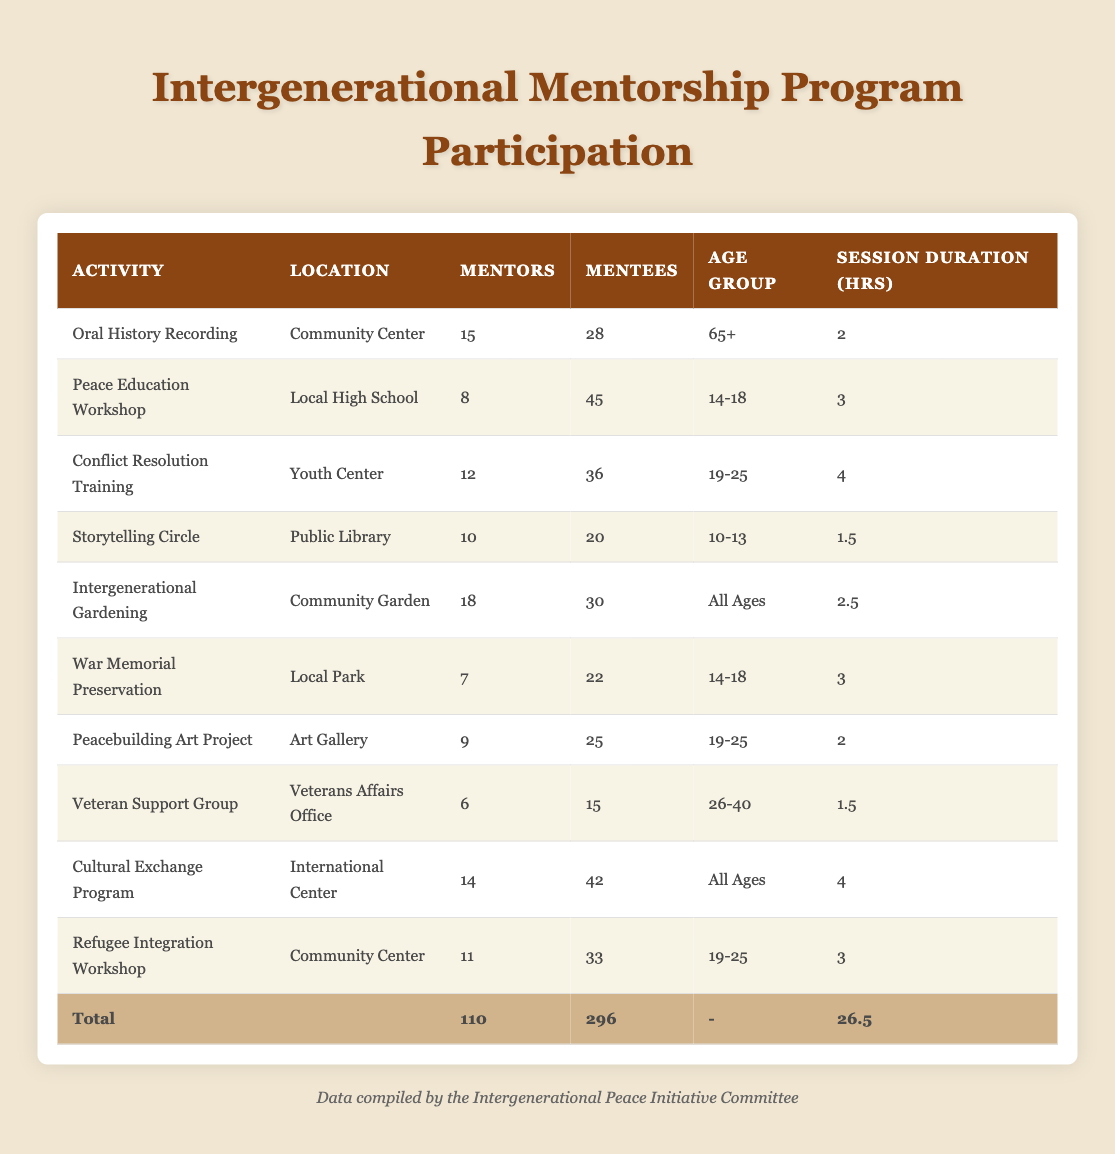What is the total number of mentees participating in the program? To find the total mentees, I will add the number of mentees from each activity. The total is calculated as: 28 + 45 + 36 + 20 + 30 + 22 + 25 + 15 + 42 + 33 = 296.
Answer: 296 Which activity located in the Community Center has the highest number of mentees? The Community Center hosts two activities: Oral History Recording and Refugee Integration Workshop. The number of mentees for Oral History Recording is 28, and for Refugee Integration Workshop, it is 33. Since 33 is greater than 28, the activity with the highest number of mentees is Refugee Integration Workshop.
Answer: Refugee Integration Workshop Are there more mentors or mentees participating in the Intergenerational Gardening activity? In the Intergenerational Gardening activity, there are 18 mentors and 30 mentees. Since 30 is greater than 18, there are more mentees than mentors in this activity.
Answer: Yes What is the average session duration for the activities involving age groups 19-25? There are three activities for the 19-25 age group: Conflict Resolution Training (4 hours), Peacebuilding Art Project (2 hours), and Refugee Integration Workshop (3 hours). To calculate the average duration: (4 + 2 + 3) / 3 = 3. So, the average session duration is 3 hours.
Answer: 3 Is the total number of mentors greater than the total number of mentors aged 14-18? The total number of mentors is 110. The activities targeted at the 14-18 age group are Peace Education Workshop with 8 mentors and War Memorial Preservation with 7 mentors. Summing these gives 8 + 7 = 15. Since 110 is greater than 15, the statement is true.
Answer: Yes Which location has the highest participation rate in terms of total mentees? To find the location with the highest mentee participation, I will sum the mentees for each location. Community Center has 61 (28 + 33), Local High School has 45, Youth Center has 36, Public Library has 20, Community Garden has 30, Local Park has 22, Art Gallery has 25, and International Center has 42. The highest total is for the Community Center.
Answer: Community Center How many different age groups are represented in the dataset? The age groups in the dataset are: 65+, 14-18, 19-25, 10-13, All Ages, and 26-40. Counting these, there are 6 distinct age groups represented.
Answer: 6 What percentage of the total mentors are participating in the Conflict Resolution Training? There are 12 mentors in the Conflict Resolution Training activity. The total number of mentors is 110. To calculate the percentage: (12 / 110) * 100 = 10.91%. So, approximately 10.91% of the mentors are participating in this activity.
Answer: 10.91% 